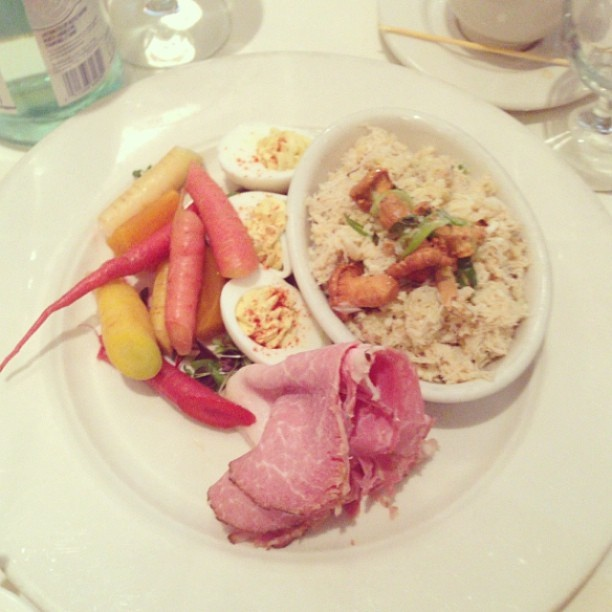Describe the objects in this image and their specific colors. I can see bowl in gray and tan tones, bottle in gray, darkgray, and beige tones, wine glass in gray and tan tones, dining table in gray, beige, and tan tones, and carrot in gray, orange, gold, and tan tones in this image. 